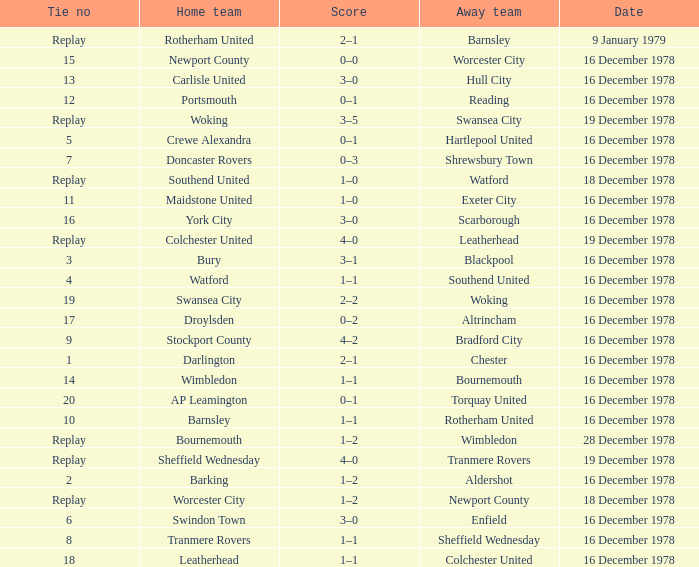What is the score for the date of 16 december 1978, with a tie no of 9? 4–2. 